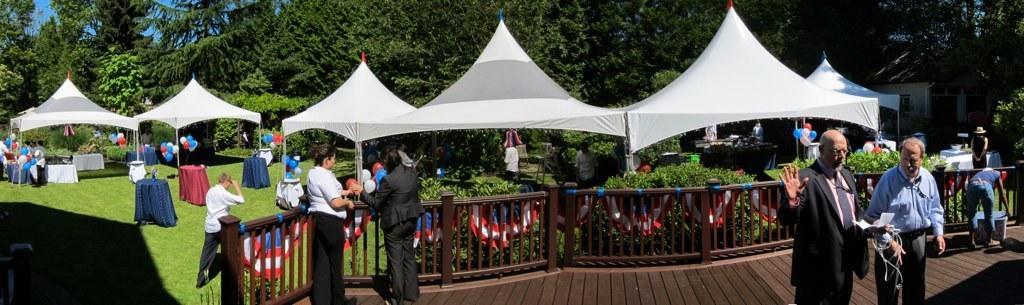Can you describe this image briefly? In this picture there are two women who are standing near to the wooden fencing. On the right there are two man standing on the wooden floor. Here we can see group of persons was standing near the tent. In the back we can see balloons, table, tent, plants and trees. On the top left corner there is a sky. On the bottom left corner we can see grass. 